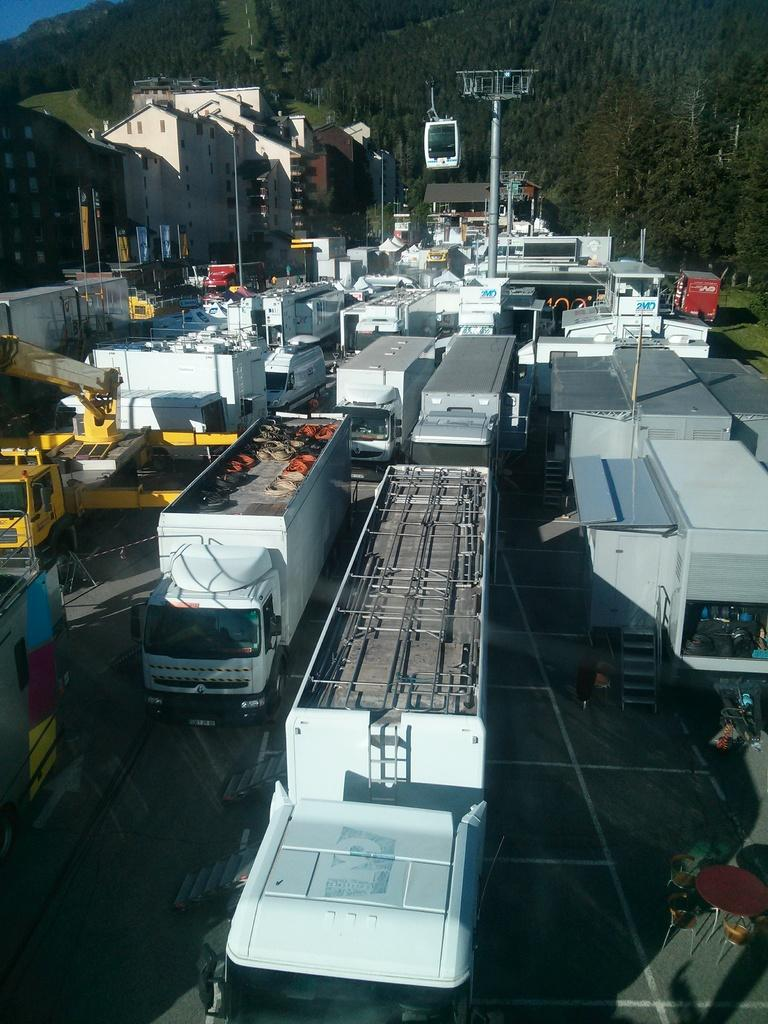What can be seen on the road in the image? There are vehicles on the road in the image. What is visible in the background of the image? There are buildings and trees in the background of the image. What objects are present in the image that are not vehicles or buildings? There are poles in the image. What type of representative animal can be seen in the image? There is no representative animal present in the image. Is there a church visible in the image? There is no church visible in the image; the image features vehicles on the road, buildings, trees, and poles. 